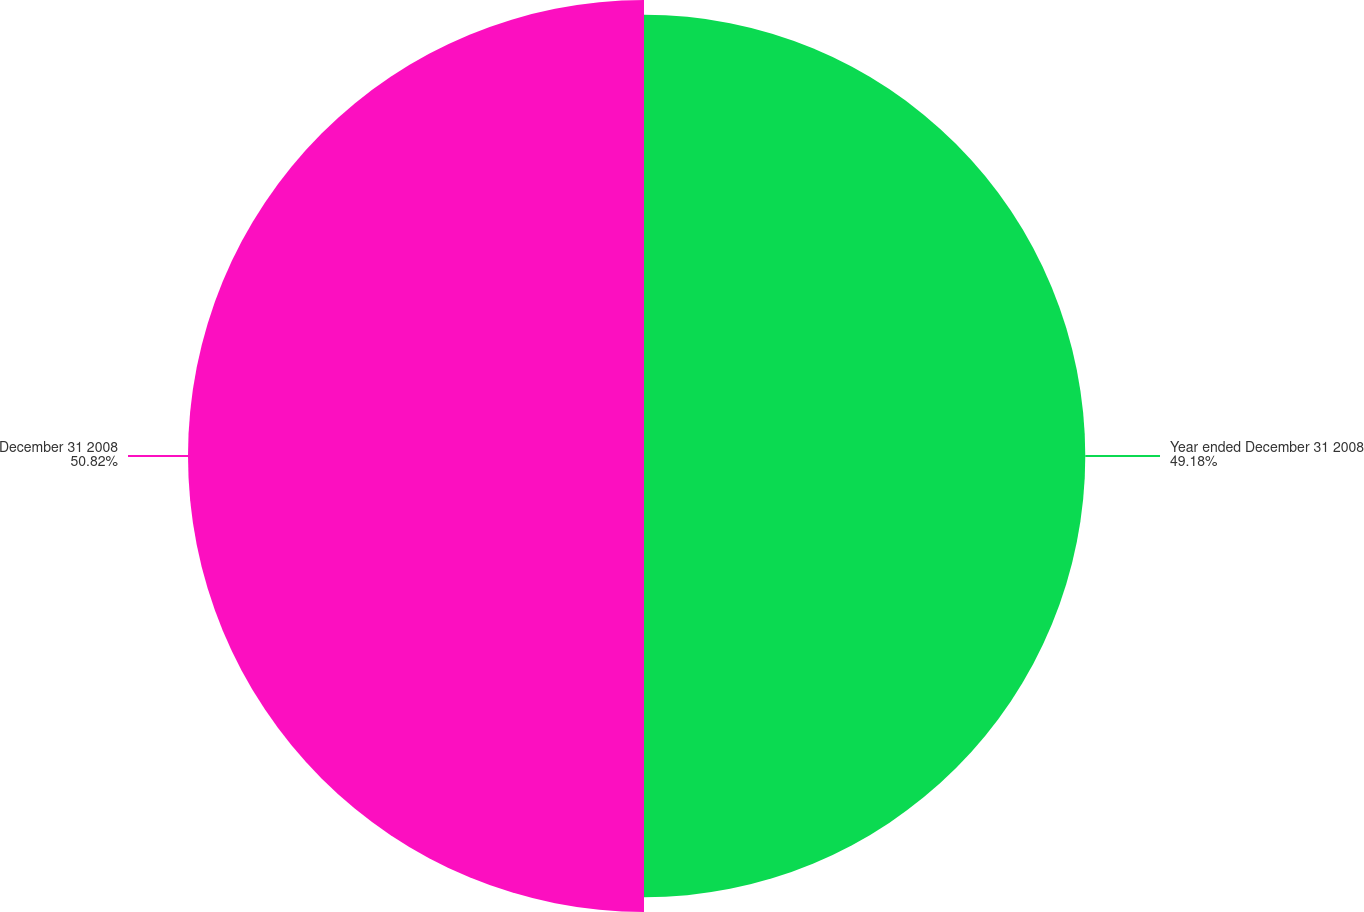Convert chart to OTSL. <chart><loc_0><loc_0><loc_500><loc_500><pie_chart><fcel>Year ended December 31 2008<fcel>December 31 2008<nl><fcel>49.18%<fcel>50.82%<nl></chart> 